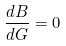<formula> <loc_0><loc_0><loc_500><loc_500>\frac { d B } { d G } = 0</formula> 